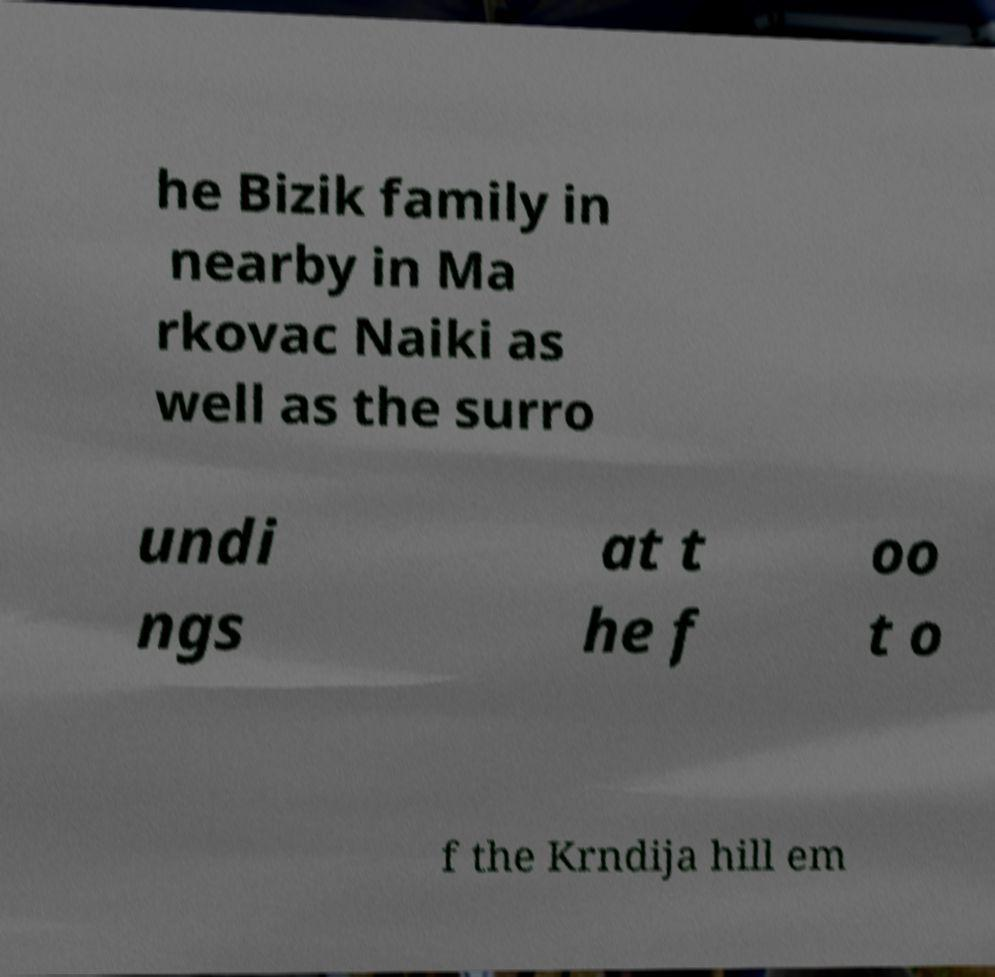Please read and relay the text visible in this image. What does it say? he Bizik family in nearby in Ma rkovac Naiki as well as the surro undi ngs at t he f oo t o f the Krndija hill em 